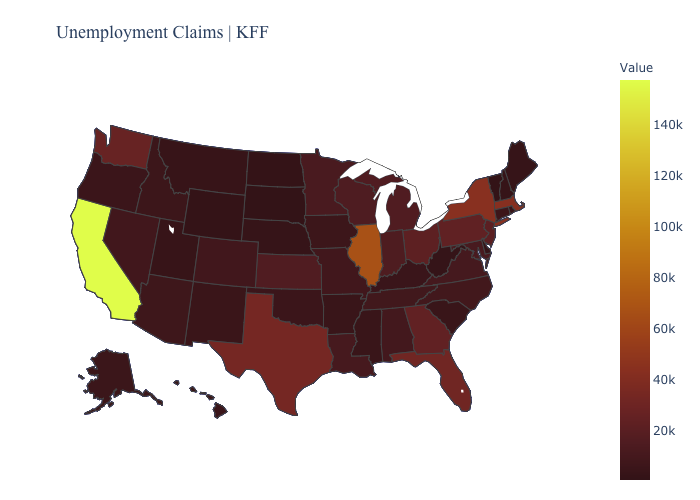Does South Dakota have the lowest value in the USA?
Keep it brief. Yes. Does Arizona have the lowest value in the USA?
Short answer required. No. Does the map have missing data?
Answer briefly. No. Which states have the lowest value in the USA?
Quick response, please. South Dakota. 